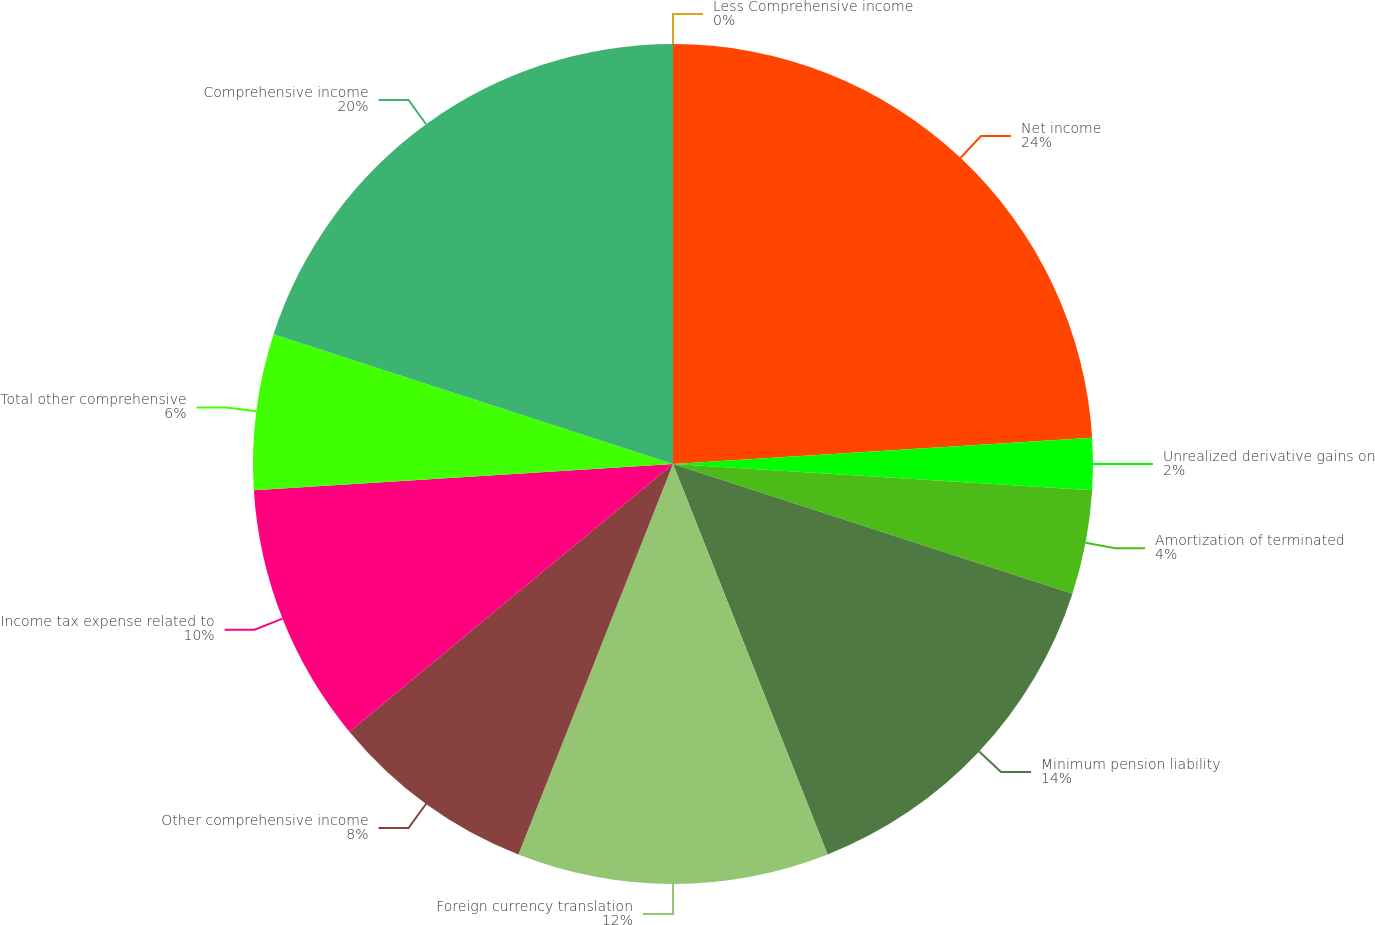Convert chart to OTSL. <chart><loc_0><loc_0><loc_500><loc_500><pie_chart><fcel>Net income<fcel>Unrealized derivative gains on<fcel>Amortization of terminated<fcel>Minimum pension liability<fcel>Foreign currency translation<fcel>Other comprehensive income<fcel>Income tax expense related to<fcel>Total other comprehensive<fcel>Comprehensive income<fcel>Less Comprehensive income<nl><fcel>24.0%<fcel>2.0%<fcel>4.0%<fcel>14.0%<fcel>12.0%<fcel>8.0%<fcel>10.0%<fcel>6.0%<fcel>20.0%<fcel>0.0%<nl></chart> 